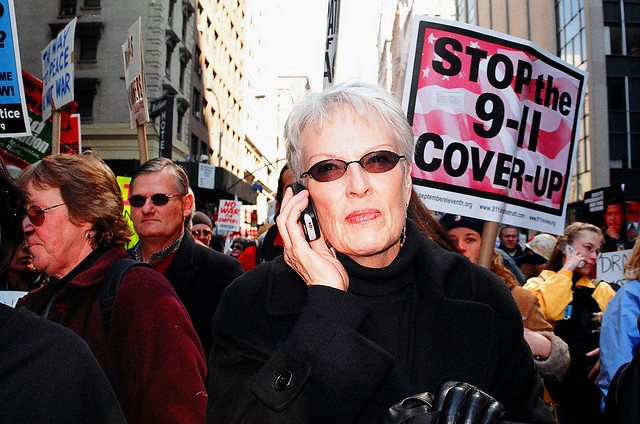Please identify all text content in this image. STOP 9 COVER UP the 11 DR PS HOTEL WAR PEICE WAY A F A tion tice w ME WAR NO 